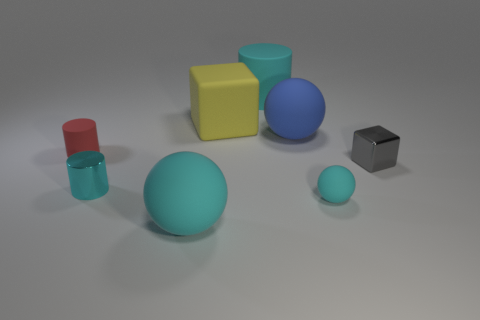Is the large matte cylinder the same color as the shiny cylinder?
Ensure brevity in your answer.  Yes. How many big red spheres have the same material as the yellow cube?
Offer a very short reply. 0. What is the color of the tiny cylinder that is the same material as the tiny gray block?
Make the answer very short. Cyan. How big is the cyan cylinder to the left of the cube that is left of the large cyan thing behind the tiny red cylinder?
Keep it short and to the point. Small. Is the number of tiny purple blocks less than the number of yellow blocks?
Provide a short and direct response. Yes. There is another large thing that is the same shape as the blue object; what is its color?
Make the answer very short. Cyan. There is a tiny rubber thing that is to the left of the block behind the red thing; is there a matte thing in front of it?
Provide a short and direct response. Yes. Does the blue object have the same shape as the yellow rubber object?
Provide a short and direct response. No. Is the number of small gray metallic things behind the large yellow cube less than the number of large cyan rubber balls?
Your response must be concise. Yes. There is a big ball that is in front of the cyan sphere that is behind the cyan matte sphere that is to the left of the big blue rubber ball; what color is it?
Offer a very short reply. Cyan. 